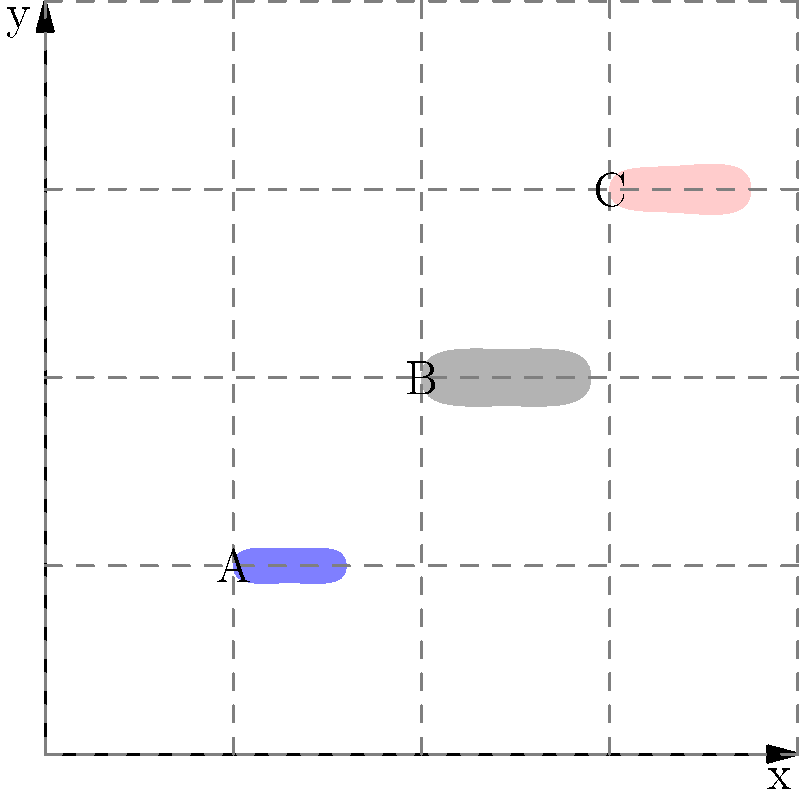Based on the underwater camera image above, which fish species is most likely represented by shape B? To identify the fish species, we need to analyze the characteristics of each shape:

1. Shape A: Slender body with a pointed snout and tail. This is typical of mackerel.

2. Shape B: Elongated body with a rounded head and tail. The body is thicker in the middle and tapers towards both ends. This shape is characteristic of cod.

3. Shape C: Similar to shape B, but with a slightly more pronounced hump behind the head and a more pointed snout. This shape is typical of haddock.

Given these observations, we can conclude that shape B most closely resembles a cod due to its elongated body, rounded head and tail, and even tapering from the middle to both ends.

As a fisherman from Penzance, Cornwall, you would be familiar with these common fish species found in the waters around the UK, particularly cod, which is an important commercial species in the region.
Answer: Cod 